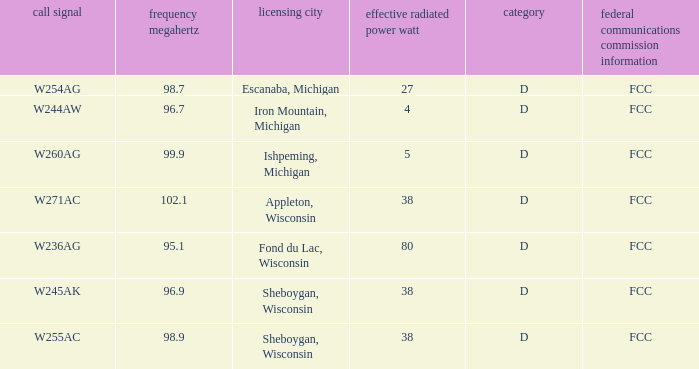What was the class for Appleton, Wisconsin? D. 